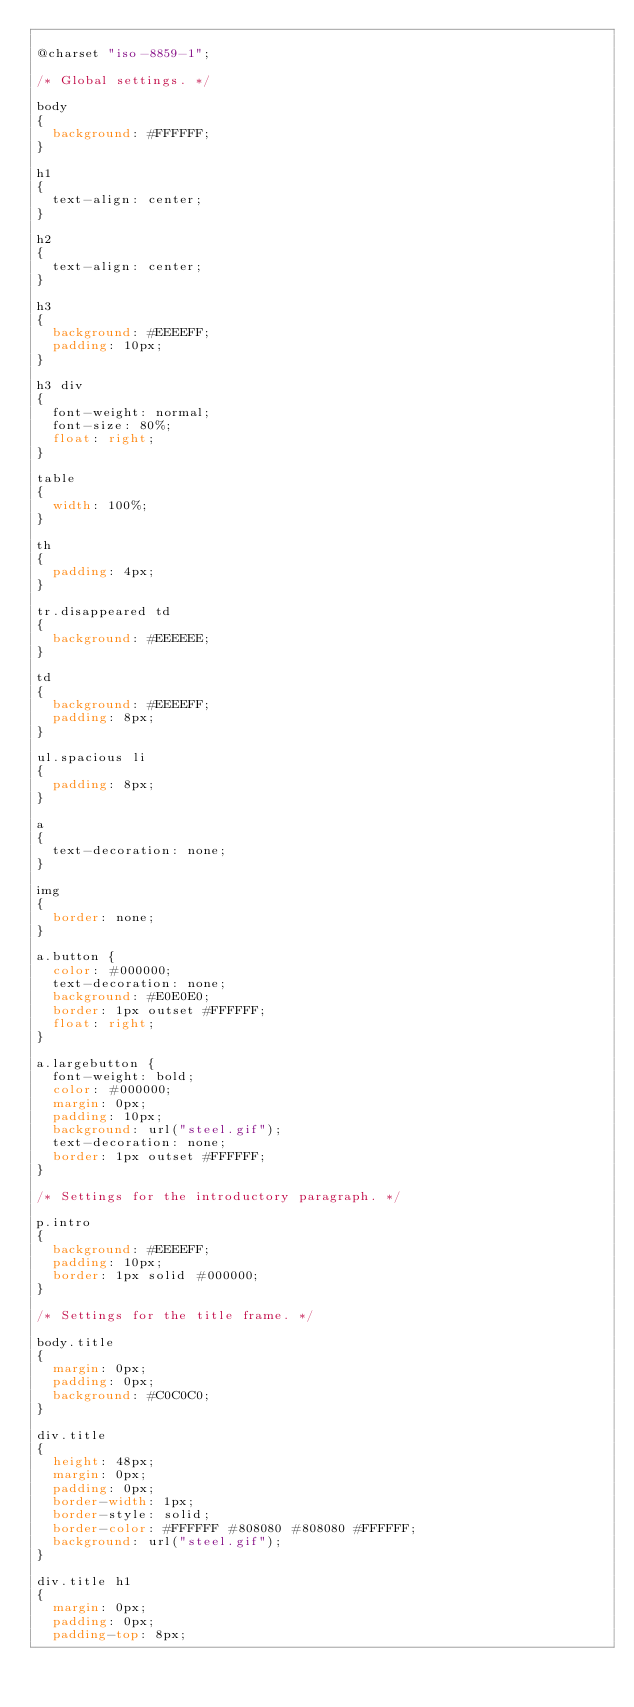Convert code to text. <code><loc_0><loc_0><loc_500><loc_500><_CSS_>
@charset "iso-8859-1";

/* Global settings. */

body
{
  background: #FFFFFF;
}

h1
{
  text-align: center;
}

h2
{
  text-align: center;
}

h3
{
  background: #EEEEFF;
  padding: 10px;
}

h3 div
{
  font-weight: normal;
  font-size: 80%;
  float: right;
}

table
{
  width: 100%;
}

th
{
  padding: 4px;
}

tr.disappeared td
{
  background: #EEEEEE;
}

td
{
  background: #EEEEFF;
  padding: 8px;
}

ul.spacious li
{
  padding: 8px;
}

a
{
  text-decoration: none;
}

img
{
  border: none;
}

a.button {
  color: #000000;
  text-decoration: none;
  background: #E0E0E0;
  border: 1px outset #FFFFFF;
  float: right;
}

a.largebutton {
  font-weight: bold;
  color: #000000;
  margin: 0px;
  padding: 10px;
  background: url("steel.gif");
  text-decoration: none;
  border: 1px outset #FFFFFF;
}

/* Settings for the introductory paragraph. */

p.intro
{
  background: #EEEEFF;
  padding: 10px;
  border: 1px solid #000000;
}

/* Settings for the title frame. */

body.title
{
  margin: 0px;
  padding: 0px;
  background: #C0C0C0;
}

div.title
{
  height: 48px;
  margin: 0px;
  padding: 0px;
  border-width: 1px;
  border-style: solid;
  border-color: #FFFFFF #808080 #808080 #FFFFFF;
  background: url("steel.gif"); 
}

div.title h1
{
  margin: 0px;
  padding: 0px;
  padding-top: 8px;</code> 